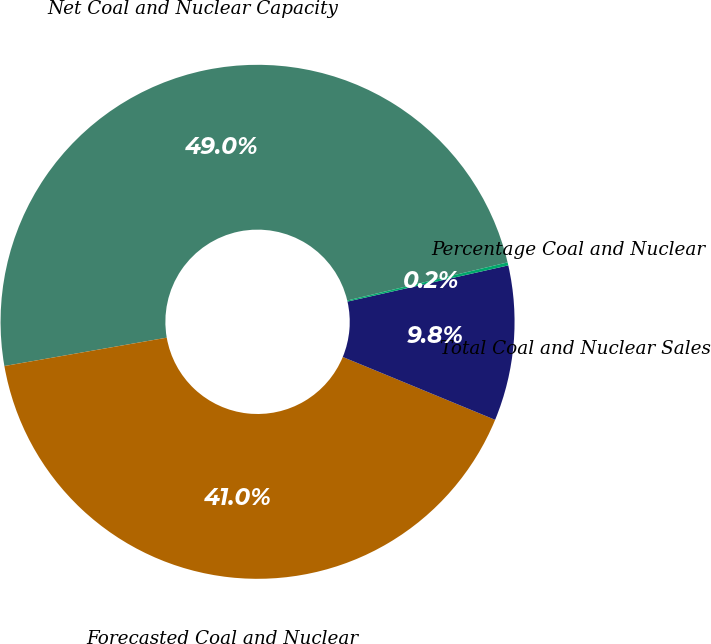Convert chart to OTSL. <chart><loc_0><loc_0><loc_500><loc_500><pie_chart><fcel>Net Coal and Nuclear Capacity<fcel>Forecasted Coal and Nuclear<fcel>Total Coal and Nuclear Sales<fcel>Percentage Coal and Nuclear<nl><fcel>49.04%<fcel>41.02%<fcel>9.75%<fcel>0.19%<nl></chart> 